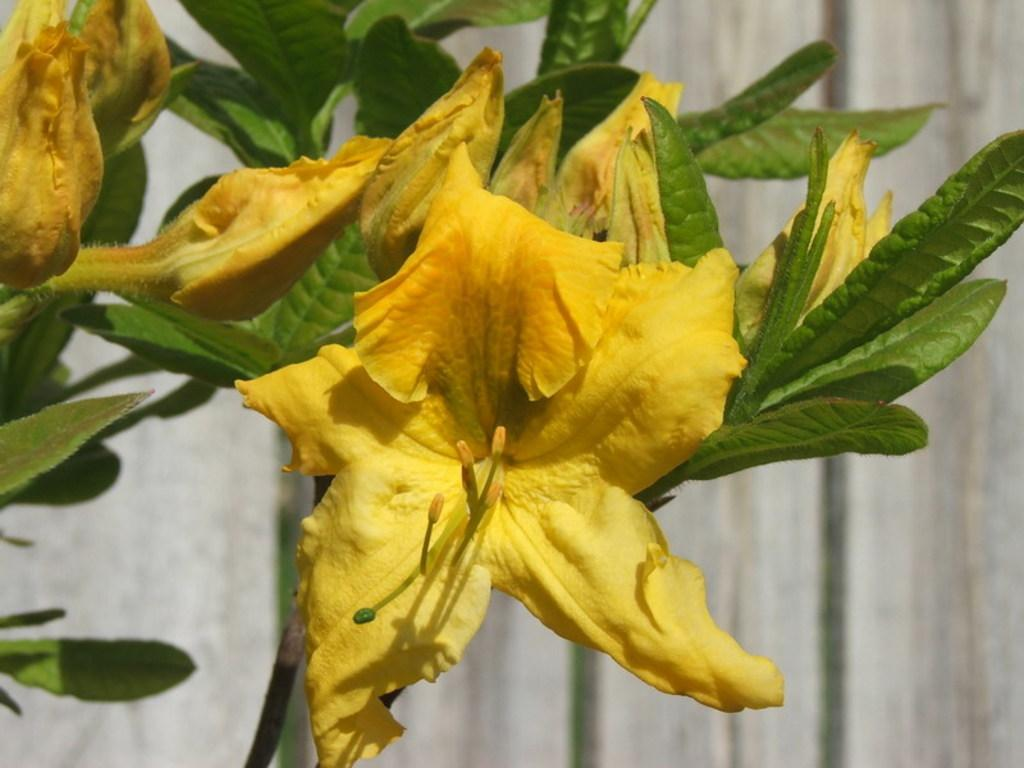What type of plant life is present in the image? There are flowers and leaves in the image. Can you describe the wooden planks visible in the background of the image? Yes, there are wooden planks visible in the background. What type of lettuce is being used to improve the acoustics in the image? There is no lettuce present in the image, and the image does not depict any acoustic improvements. 